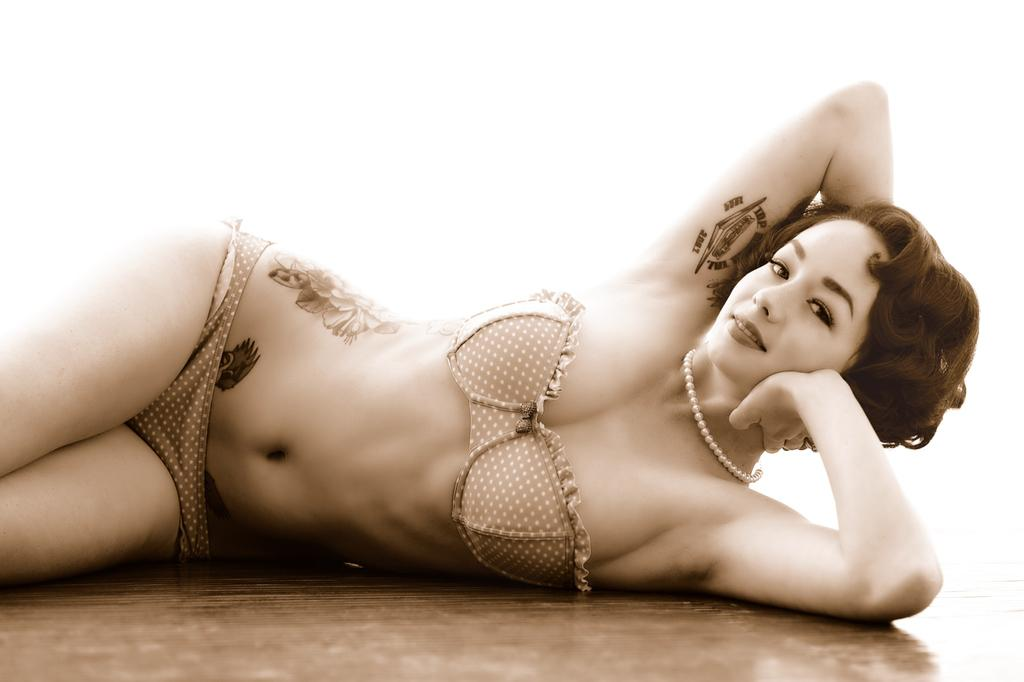Who is the main subject in the foreground of the image? There is a woman in the foreground of the image. What is the woman laying on in the image? The woman is laying on a wooden surface. What color is the background of the image? The background of the image is white. How many dogs are visible in the image? There are no dogs present in the image. What is the woman pointing at in the image? The woman is not pointing at anything in the image. 